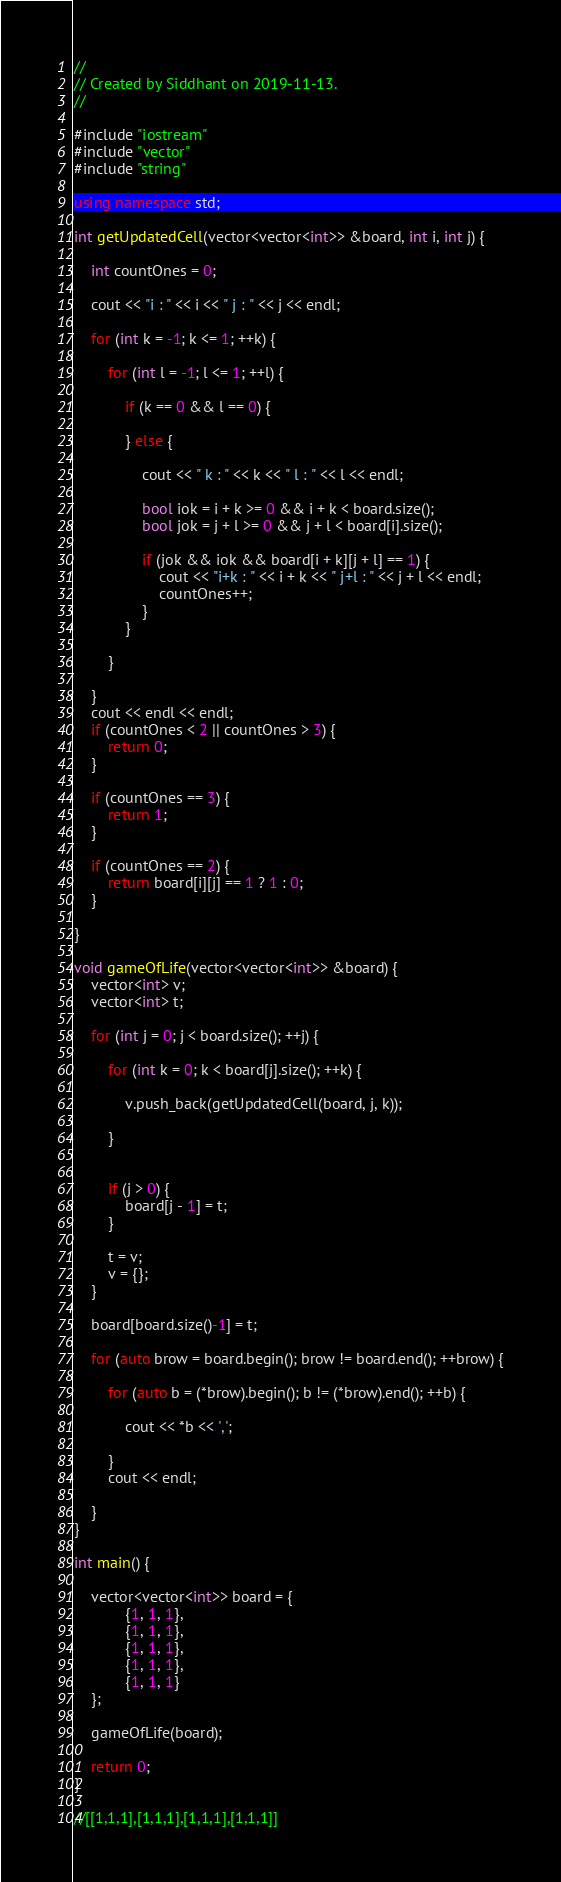<code> <loc_0><loc_0><loc_500><loc_500><_C++_>//
// Created by Siddhant on 2019-11-13.
//

#include "iostream"
#include "vector"
#include "string"

using namespace std;

int getUpdatedCell(vector<vector<int>> &board, int i, int j) {

    int countOnes = 0;

    cout << "i : " << i << " j : " << j << endl;

    for (int k = -1; k <= 1; ++k) {

        for (int l = -1; l <= 1; ++l) {

            if (k == 0 && l == 0) {

            } else {

                cout << " k : " << k << " l : " << l << endl;

                bool iok = i + k >= 0 && i + k < board.size();
                bool jok = j + l >= 0 && j + l < board[i].size();

                if (jok && iok && board[i + k][j + l] == 1) {
                    cout << "i+k : " << i + k << " j+l : " << j + l << endl;
                    countOnes++;
                }
            }

        }

    }
    cout << endl << endl;
    if (countOnes < 2 || countOnes > 3) {
        return 0;
    }

    if (countOnes == 3) {
        return 1;
    }

    if (countOnes == 2) {
        return board[i][j] == 1 ? 1 : 0;
    }

}

void gameOfLife(vector<vector<int>> &board) {
    vector<int> v;
    vector<int> t;

    for (int j = 0; j < board.size(); ++j) {

        for (int k = 0; k < board[j].size(); ++k) {

            v.push_back(getUpdatedCell(board, j, k));

        }


        if (j > 0) {
            board[j - 1] = t;
        }

        t = v;
        v = {};
    }

    board[board.size()-1] = t;

    for (auto brow = board.begin(); brow != board.end(); ++brow) {

        for (auto b = (*brow).begin(); b != (*brow).end(); ++b) {

            cout << *b << ',';

        }
        cout << endl;

    }
}

int main() {

    vector<vector<int>> board = {
            {1, 1, 1},
            {1, 1, 1},
            {1, 1, 1},
            {1, 1, 1},
            {1, 1, 1}
    };

    gameOfLife(board);

    return 0;
}

//[[1,1,1],[1,1,1],[1,1,1],[1,1,1]]</code> 